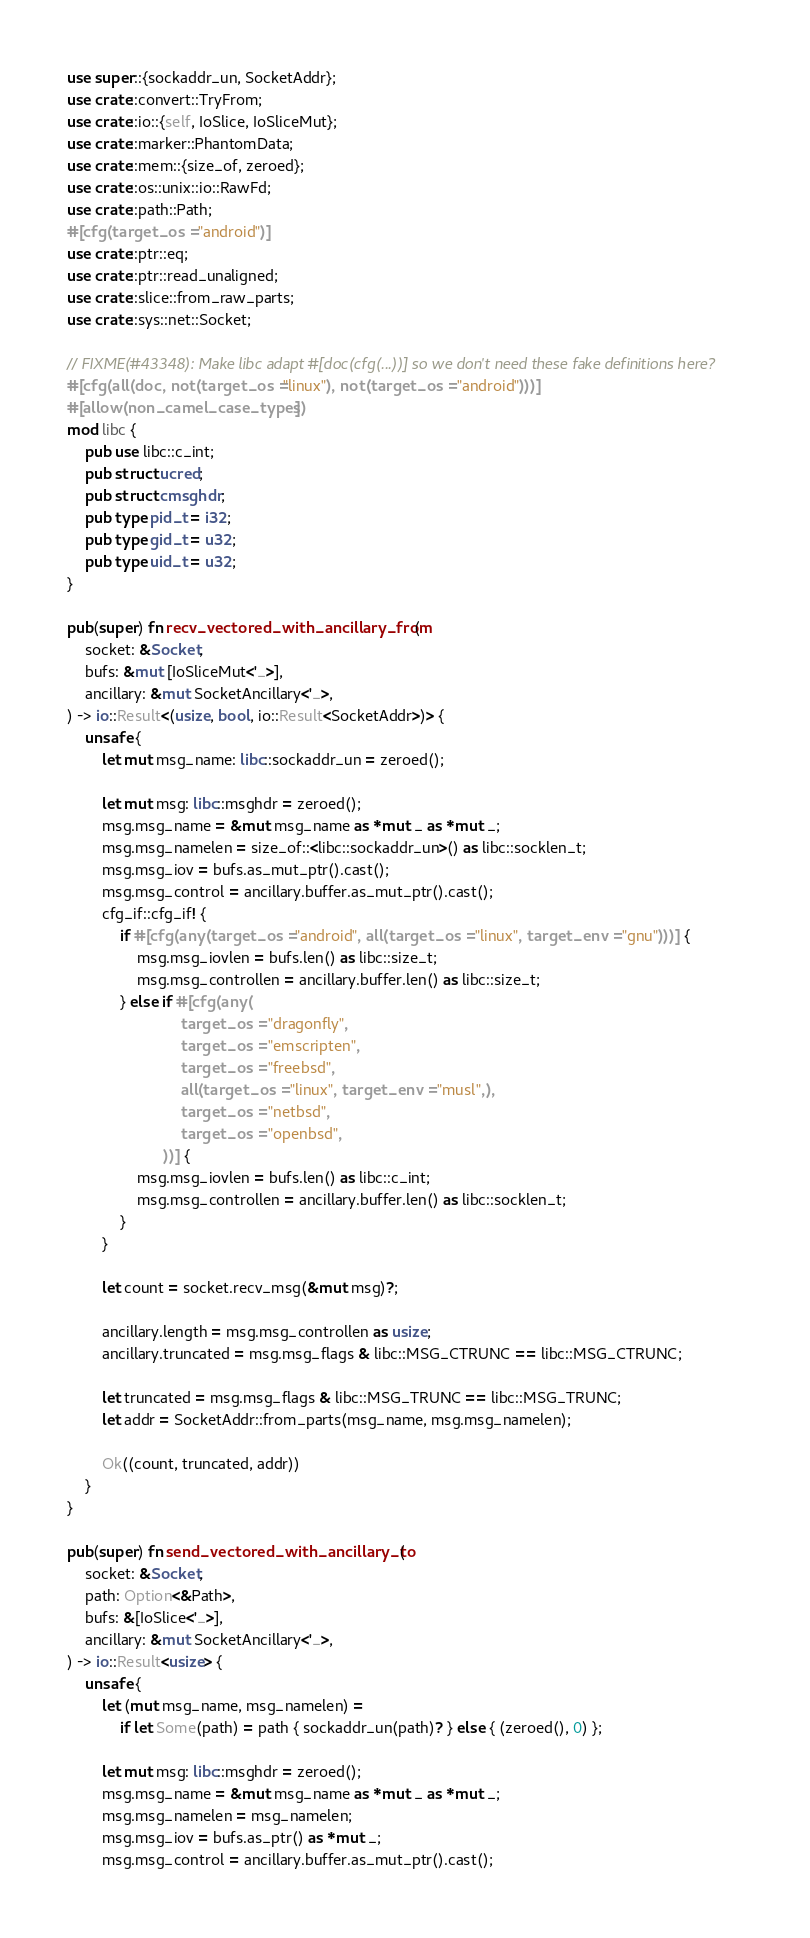<code> <loc_0><loc_0><loc_500><loc_500><_Rust_>use super::{sockaddr_un, SocketAddr};
use crate::convert::TryFrom;
use crate::io::{self, IoSlice, IoSliceMut};
use crate::marker::PhantomData;
use crate::mem::{size_of, zeroed};
use crate::os::unix::io::RawFd;
use crate::path::Path;
#[cfg(target_os = "android")]
use crate::ptr::eq;
use crate::ptr::read_unaligned;
use crate::slice::from_raw_parts;
use crate::sys::net::Socket;

// FIXME(#43348): Make libc adapt #[doc(cfg(...))] so we don't need these fake definitions here?
#[cfg(all(doc, not(target_os = "linux"), not(target_os = "android")))]
#[allow(non_camel_case_types)]
mod libc {
    pub use libc::c_int;
    pub struct ucred;
    pub struct cmsghdr;
    pub type pid_t = i32;
    pub type gid_t = u32;
    pub type uid_t = u32;
}

pub(super) fn recv_vectored_with_ancillary_from(
    socket: &Socket,
    bufs: &mut [IoSliceMut<'_>],
    ancillary: &mut SocketAncillary<'_>,
) -> io::Result<(usize, bool, io::Result<SocketAddr>)> {
    unsafe {
        let mut msg_name: libc::sockaddr_un = zeroed();

        let mut msg: libc::msghdr = zeroed();
        msg.msg_name = &mut msg_name as *mut _ as *mut _;
        msg.msg_namelen = size_of::<libc::sockaddr_un>() as libc::socklen_t;
        msg.msg_iov = bufs.as_mut_ptr().cast();
        msg.msg_control = ancillary.buffer.as_mut_ptr().cast();
        cfg_if::cfg_if! {
            if #[cfg(any(target_os = "android", all(target_os = "linux", target_env = "gnu")))] {
                msg.msg_iovlen = bufs.len() as libc::size_t;
                msg.msg_controllen = ancillary.buffer.len() as libc::size_t;
            } else if #[cfg(any(
                          target_os = "dragonfly",
                          target_os = "emscripten",
                          target_os = "freebsd",
                          all(target_os = "linux", target_env = "musl",),
                          target_os = "netbsd",
                          target_os = "openbsd",
                      ))] {
                msg.msg_iovlen = bufs.len() as libc::c_int;
                msg.msg_controllen = ancillary.buffer.len() as libc::socklen_t;
            }
        }

        let count = socket.recv_msg(&mut msg)?;

        ancillary.length = msg.msg_controllen as usize;
        ancillary.truncated = msg.msg_flags & libc::MSG_CTRUNC == libc::MSG_CTRUNC;

        let truncated = msg.msg_flags & libc::MSG_TRUNC == libc::MSG_TRUNC;
        let addr = SocketAddr::from_parts(msg_name, msg.msg_namelen);

        Ok((count, truncated, addr))
    }
}

pub(super) fn send_vectored_with_ancillary_to(
    socket: &Socket,
    path: Option<&Path>,
    bufs: &[IoSlice<'_>],
    ancillary: &mut SocketAncillary<'_>,
) -> io::Result<usize> {
    unsafe {
        let (mut msg_name, msg_namelen) =
            if let Some(path) = path { sockaddr_un(path)? } else { (zeroed(), 0) };

        let mut msg: libc::msghdr = zeroed();
        msg.msg_name = &mut msg_name as *mut _ as *mut _;
        msg.msg_namelen = msg_namelen;
        msg.msg_iov = bufs.as_ptr() as *mut _;
        msg.msg_control = ancillary.buffer.as_mut_ptr().cast();</code> 